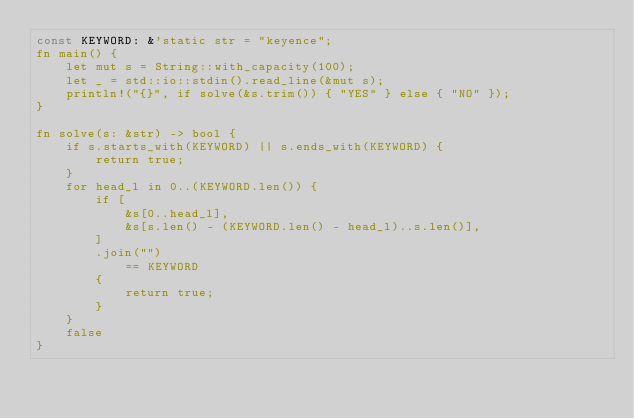<code> <loc_0><loc_0><loc_500><loc_500><_Rust_>const KEYWORD: &'static str = "keyence";
fn main() {
    let mut s = String::with_capacity(100);
    let _ = std::io::stdin().read_line(&mut s);
    println!("{}", if solve(&s.trim()) { "YES" } else { "NO" });
}

fn solve(s: &str) -> bool {
    if s.starts_with(KEYWORD) || s.ends_with(KEYWORD) {
        return true;
    }
    for head_l in 0..(KEYWORD.len()) {
        if [
            &s[0..head_l],
            &s[s.len() - (KEYWORD.len() - head_l)..s.len()],
        ]
        .join("")
            == KEYWORD
        {
            return true;
        }
    }
    false
}
</code> 